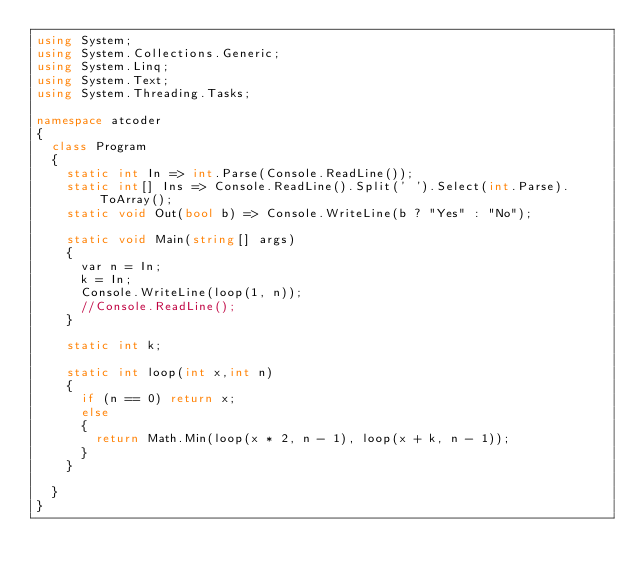Convert code to text. <code><loc_0><loc_0><loc_500><loc_500><_C#_>using System;
using System.Collections.Generic;
using System.Linq;
using System.Text;
using System.Threading.Tasks;

namespace atcoder
{
	class Program
	{
		static int In => int.Parse(Console.ReadLine());
		static int[] Ins => Console.ReadLine().Split(' ').Select(int.Parse).ToArray();
		static void Out(bool b) => Console.WriteLine(b ? "Yes" : "No");

		static void Main(string[] args)
		{
			var n = In;
			k = In;
			Console.WriteLine(loop(1, n));
			//Console.ReadLine();
		}

		static int k;

		static int loop(int x,int n)
		{
			if (n == 0) return x;
			else
			{
				return Math.Min(loop(x * 2, n - 1), loop(x + k, n - 1));
			}
		}
		
	}
}</code> 